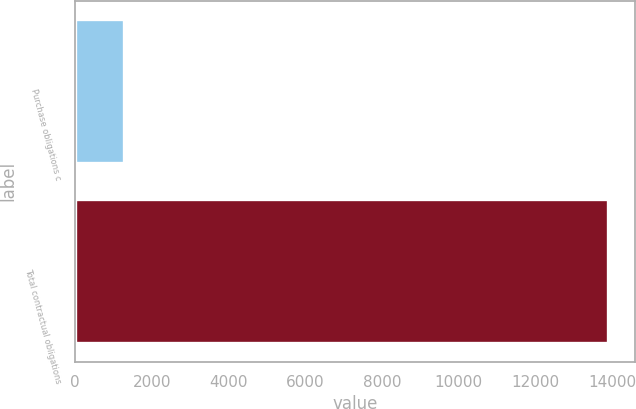<chart> <loc_0><loc_0><loc_500><loc_500><bar_chart><fcel>Purchase obligations c<fcel>Total contractual obligations<nl><fcel>1284<fcel>13893<nl></chart> 